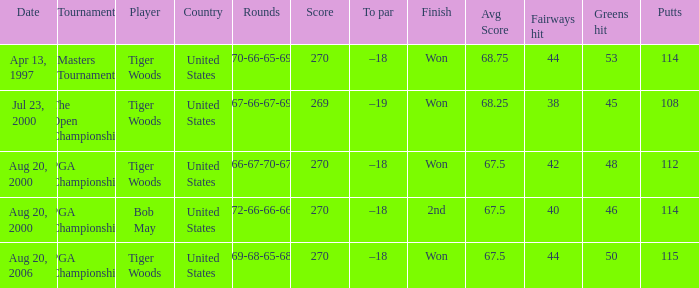What country hosts the tournament the open championship? United States. 